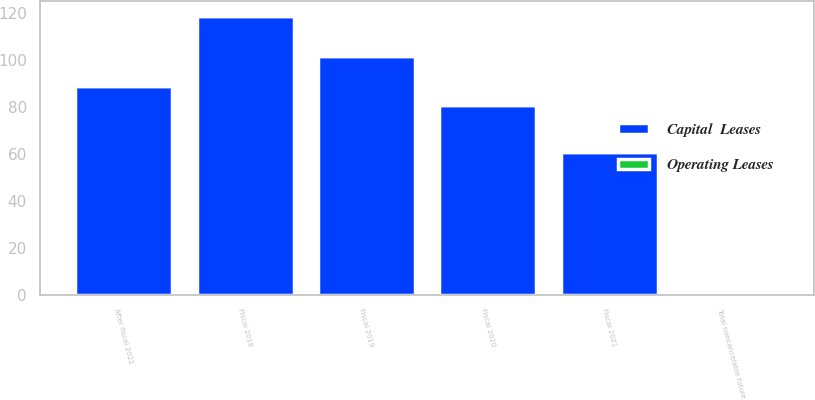<chart> <loc_0><loc_0><loc_500><loc_500><stacked_bar_chart><ecel><fcel>Fiscal 2018<fcel>Fiscal 2019<fcel>Fiscal 2020<fcel>Fiscal 2021<fcel>After fiscal 2022<fcel>Total noncancelable future<nl><fcel>Capital  Leases<fcel>118.8<fcel>101.7<fcel>80.7<fcel>60.7<fcel>89.1<fcel>1.2<nl><fcel>Operating Leases<fcel>0.4<fcel>0.4<fcel>0.2<fcel>0.1<fcel>0.1<fcel>1.2<nl></chart> 